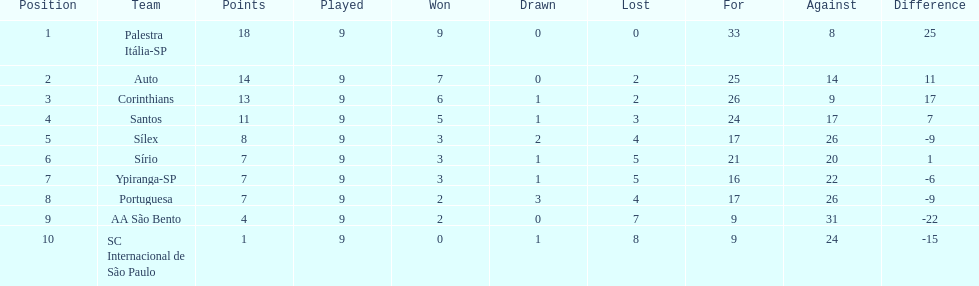In the 1926 brazilian football season, how many squads accumulated over 10 points? 4. 